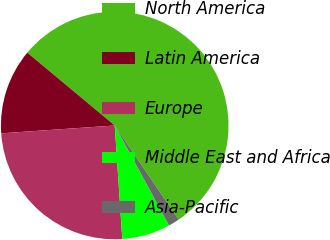Convert chart to OTSL. <chart><loc_0><loc_0><loc_500><loc_500><pie_chart><fcel>North America<fcel>Latin America<fcel>Europe<fcel>Middle East and Africa<fcel>Asia-Pacific<nl><fcel>54.45%<fcel>12.15%<fcel>24.96%<fcel>6.86%<fcel>1.57%<nl></chart> 